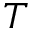Convert formula to latex. <formula><loc_0><loc_0><loc_500><loc_500>T</formula> 